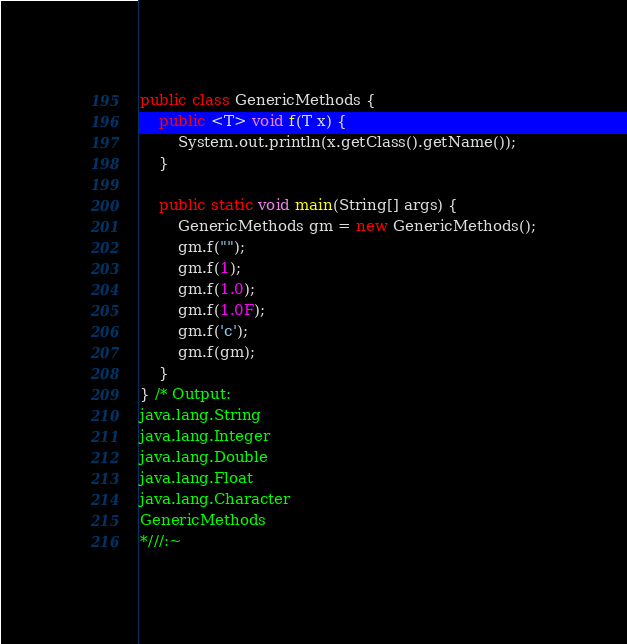<code> <loc_0><loc_0><loc_500><loc_500><_Java_>
public class GenericMethods {
    public <T> void f(T x) {
        System.out.println(x.getClass().getName());
    }

    public static void main(String[] args) {
        GenericMethods gm = new GenericMethods();
        gm.f("");
        gm.f(1);
        gm.f(1.0);
        gm.f(1.0F);
        gm.f('c');
        gm.f(gm);
    }
} /* Output:
java.lang.String
java.lang.Integer
java.lang.Double
java.lang.Float
java.lang.Character
GenericMethods
*///:~
</code> 